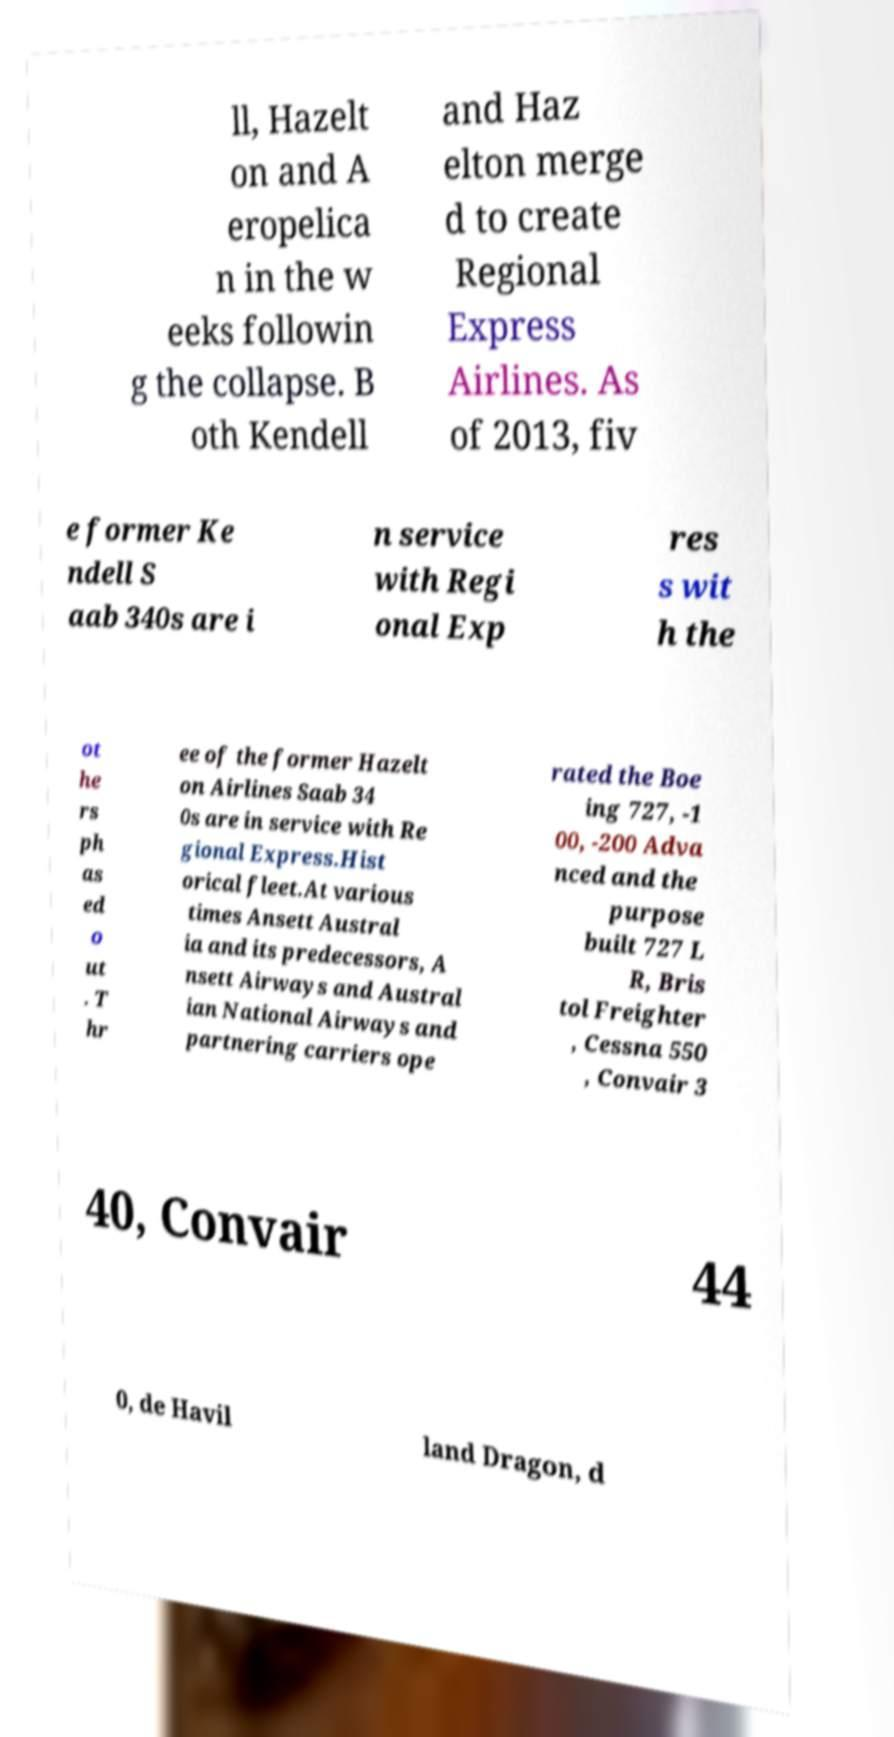I need the written content from this picture converted into text. Can you do that? ll, Hazelt on and A eropelica n in the w eeks followin g the collapse. B oth Kendell and Haz elton merge d to create Regional Express Airlines. As of 2013, fiv e former Ke ndell S aab 340s are i n service with Regi onal Exp res s wit h the ot he rs ph as ed o ut . T hr ee of the former Hazelt on Airlines Saab 34 0s are in service with Re gional Express.Hist orical fleet.At various times Ansett Austral ia and its predecessors, A nsett Airways and Austral ian National Airways and partnering carriers ope rated the Boe ing 727, -1 00, -200 Adva nced and the purpose built 727 L R, Bris tol Freighter , Cessna 550 , Convair 3 40, Convair 44 0, de Havil land Dragon, d 